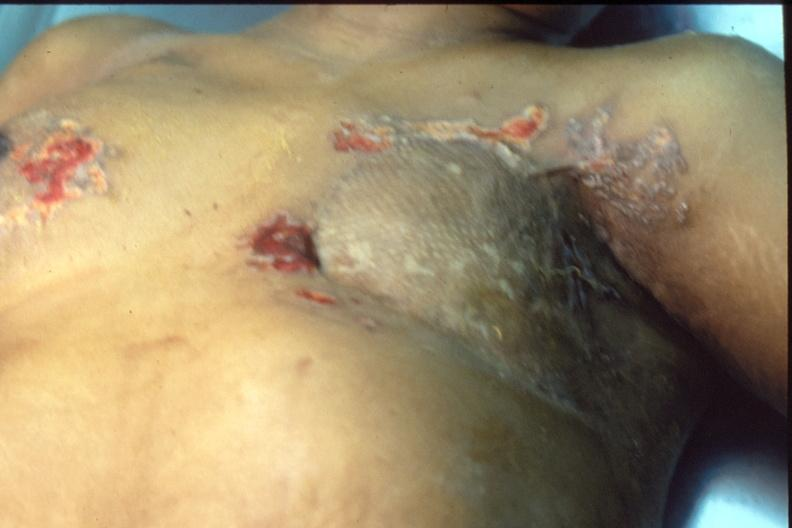how does this image show mastectomy scars?
Answer the question using a single word or phrase. With skin metastases 